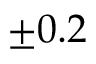<formula> <loc_0><loc_0><loc_500><loc_500>\pm 0 . 2</formula> 